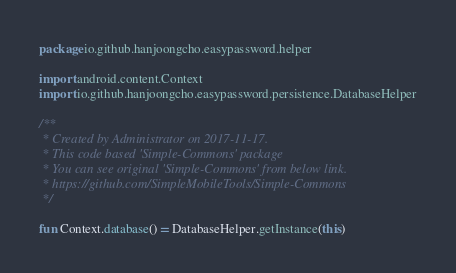Convert code to text. <code><loc_0><loc_0><loc_500><loc_500><_Kotlin_>package io.github.hanjoongcho.easypassword.helper

import android.content.Context
import io.github.hanjoongcho.easypassword.persistence.DatabaseHelper

/**
 * Created by Administrator on 2017-11-17.
 * This code based 'Simple-Commons' package
 * You can see original 'Simple-Commons' from below link.
 * https://github.com/SimpleMobileTools/Simple-Commons
 */

fun Context.database() = DatabaseHelper.getInstance(this)
</code> 